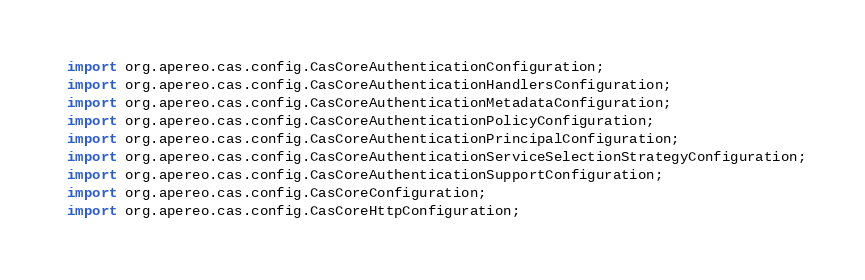<code> <loc_0><loc_0><loc_500><loc_500><_Java_>import org.apereo.cas.config.CasCoreAuthenticationConfiguration;
import org.apereo.cas.config.CasCoreAuthenticationHandlersConfiguration;
import org.apereo.cas.config.CasCoreAuthenticationMetadataConfiguration;
import org.apereo.cas.config.CasCoreAuthenticationPolicyConfiguration;
import org.apereo.cas.config.CasCoreAuthenticationPrincipalConfiguration;
import org.apereo.cas.config.CasCoreAuthenticationServiceSelectionStrategyConfiguration;
import org.apereo.cas.config.CasCoreAuthenticationSupportConfiguration;
import org.apereo.cas.config.CasCoreConfiguration;
import org.apereo.cas.config.CasCoreHttpConfiguration;</code> 